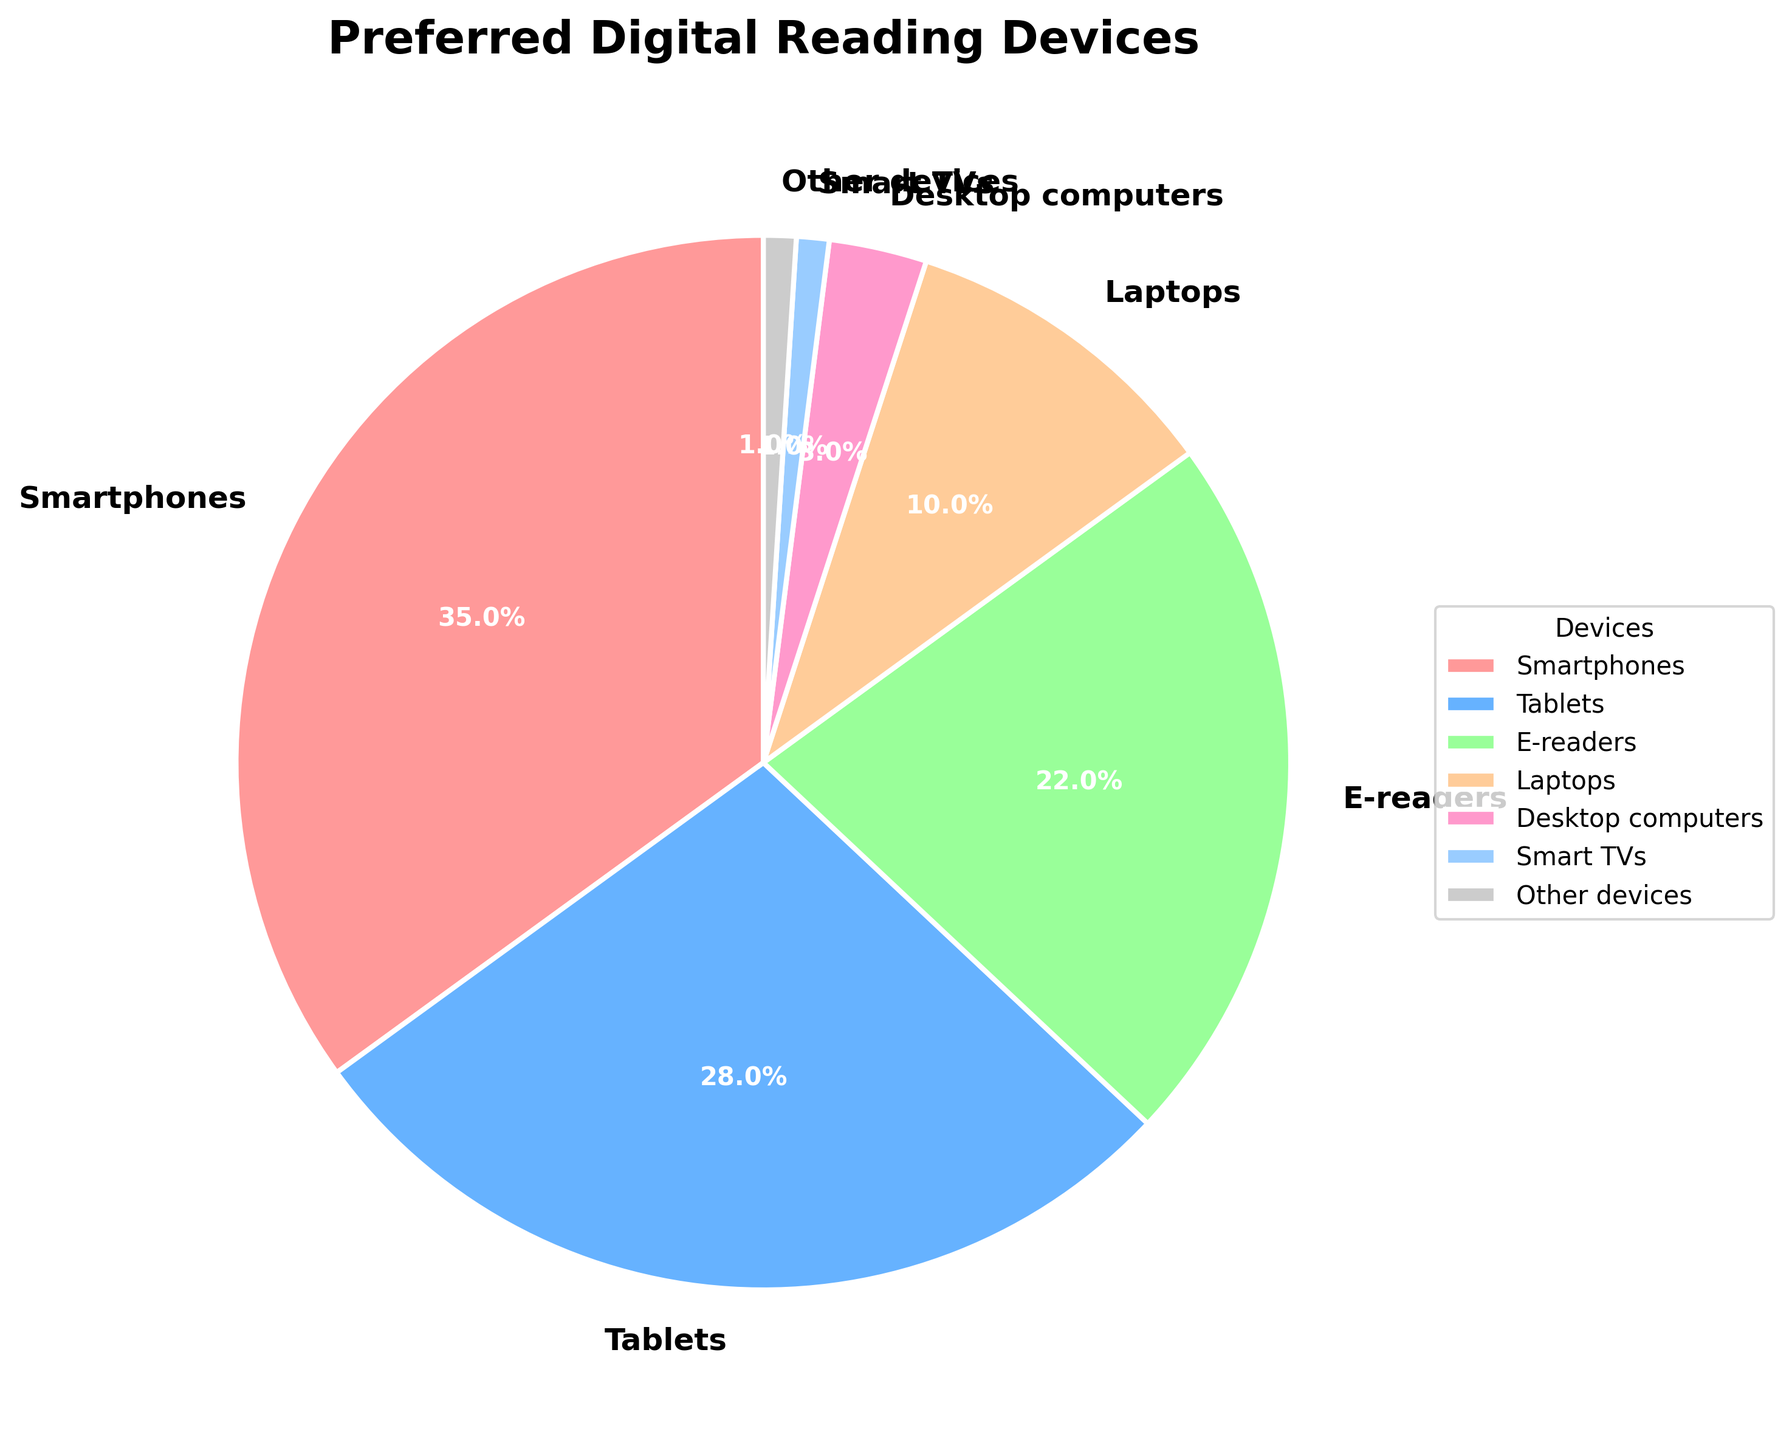What is the most preferred digital reading device among e-book consumers? The pie chart shows that Smartphones have the largest slice, indicating they are the most preferred device.
Answer: Smartphones What percentage of consumers prefer e-readers over laptops? According to the pie chart, 22% of consumers prefer e-readers whereas 10% prefer laptops. The difference is 22% - 10% = 12%.
Answer: 12% Which device has the least preference among e-book consumers? The smallest slice in the pie chart represents Smart TVs and Other devices, each with 1%.
Answer: Smart TVs and Other devices What is the combined percentage of consumers who prefer reading on smartphones and tablets? The pie chart shows 35% for Smartphones and 28% for Tablets. Combined, this is 35% + 28% = 63%.
Answer: 63% Are more consumers using e-readers or desktop computers for reading e-books? The pie chart shows that 22% of consumers use e-readers and 3% use desktop computers. The larger percentage is for e-readers.
Answer: E-readers How much more preferred are tablets compared to laptops? Tablets have a preference of 28%, while laptops have 10%. The difference is 28% - 10% = 18%.
Answer: 18% Among all devices, which one shows a preference less than 5%? According to the pie chart, Desktop computers (3%), Smart TVs (1%), and Other devices (1%) each show a preference less than 5%.
Answer: Desktop computers, Smart TVs, and Other devices What is the total percentage of consumers who do not prefer reading on e-book specific devices? (i.e., excluding e-readers) Adding percentages of smartphones (35%), tablets (28%), laptops (10%), desktop computers (3%), smart TVs (1%), and other devices (1%): 35% + 28% + 10% + 3% + 1% + 1% = 78%
Answer: 78% How many devices have a preference percentage greater than or equal to 20%? The pie chart indicates that Smartphones (35%), Tablets (28%), and E-readers (22%) each have a preference percentage greater than or equal to 20%. This makes a total of 3 devices.
Answer: 3 devices 